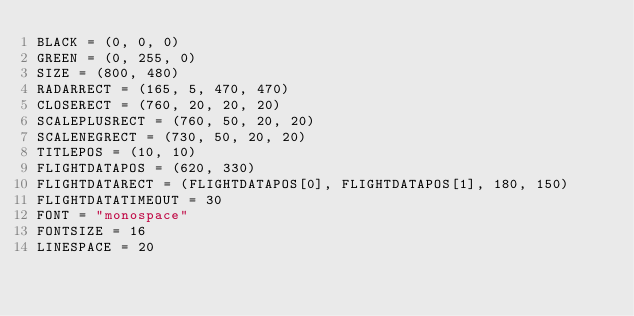Convert code to text. <code><loc_0><loc_0><loc_500><loc_500><_Python_>BLACK = (0, 0, 0)
GREEN = (0, 255, 0)
SIZE = (800, 480)
RADARRECT = (165, 5, 470, 470)
CLOSERECT = (760, 20, 20, 20)
SCALEPLUSRECT = (760, 50, 20, 20)
SCALENEGRECT = (730, 50, 20, 20)
TITLEPOS = (10, 10)
FLIGHTDATAPOS = (620, 330)
FLIGHTDATARECT = (FLIGHTDATAPOS[0], FLIGHTDATAPOS[1], 180, 150)
FLIGHTDATATIMEOUT = 30
FONT = "monospace"
FONTSIZE = 16
LINESPACE = 20</code> 